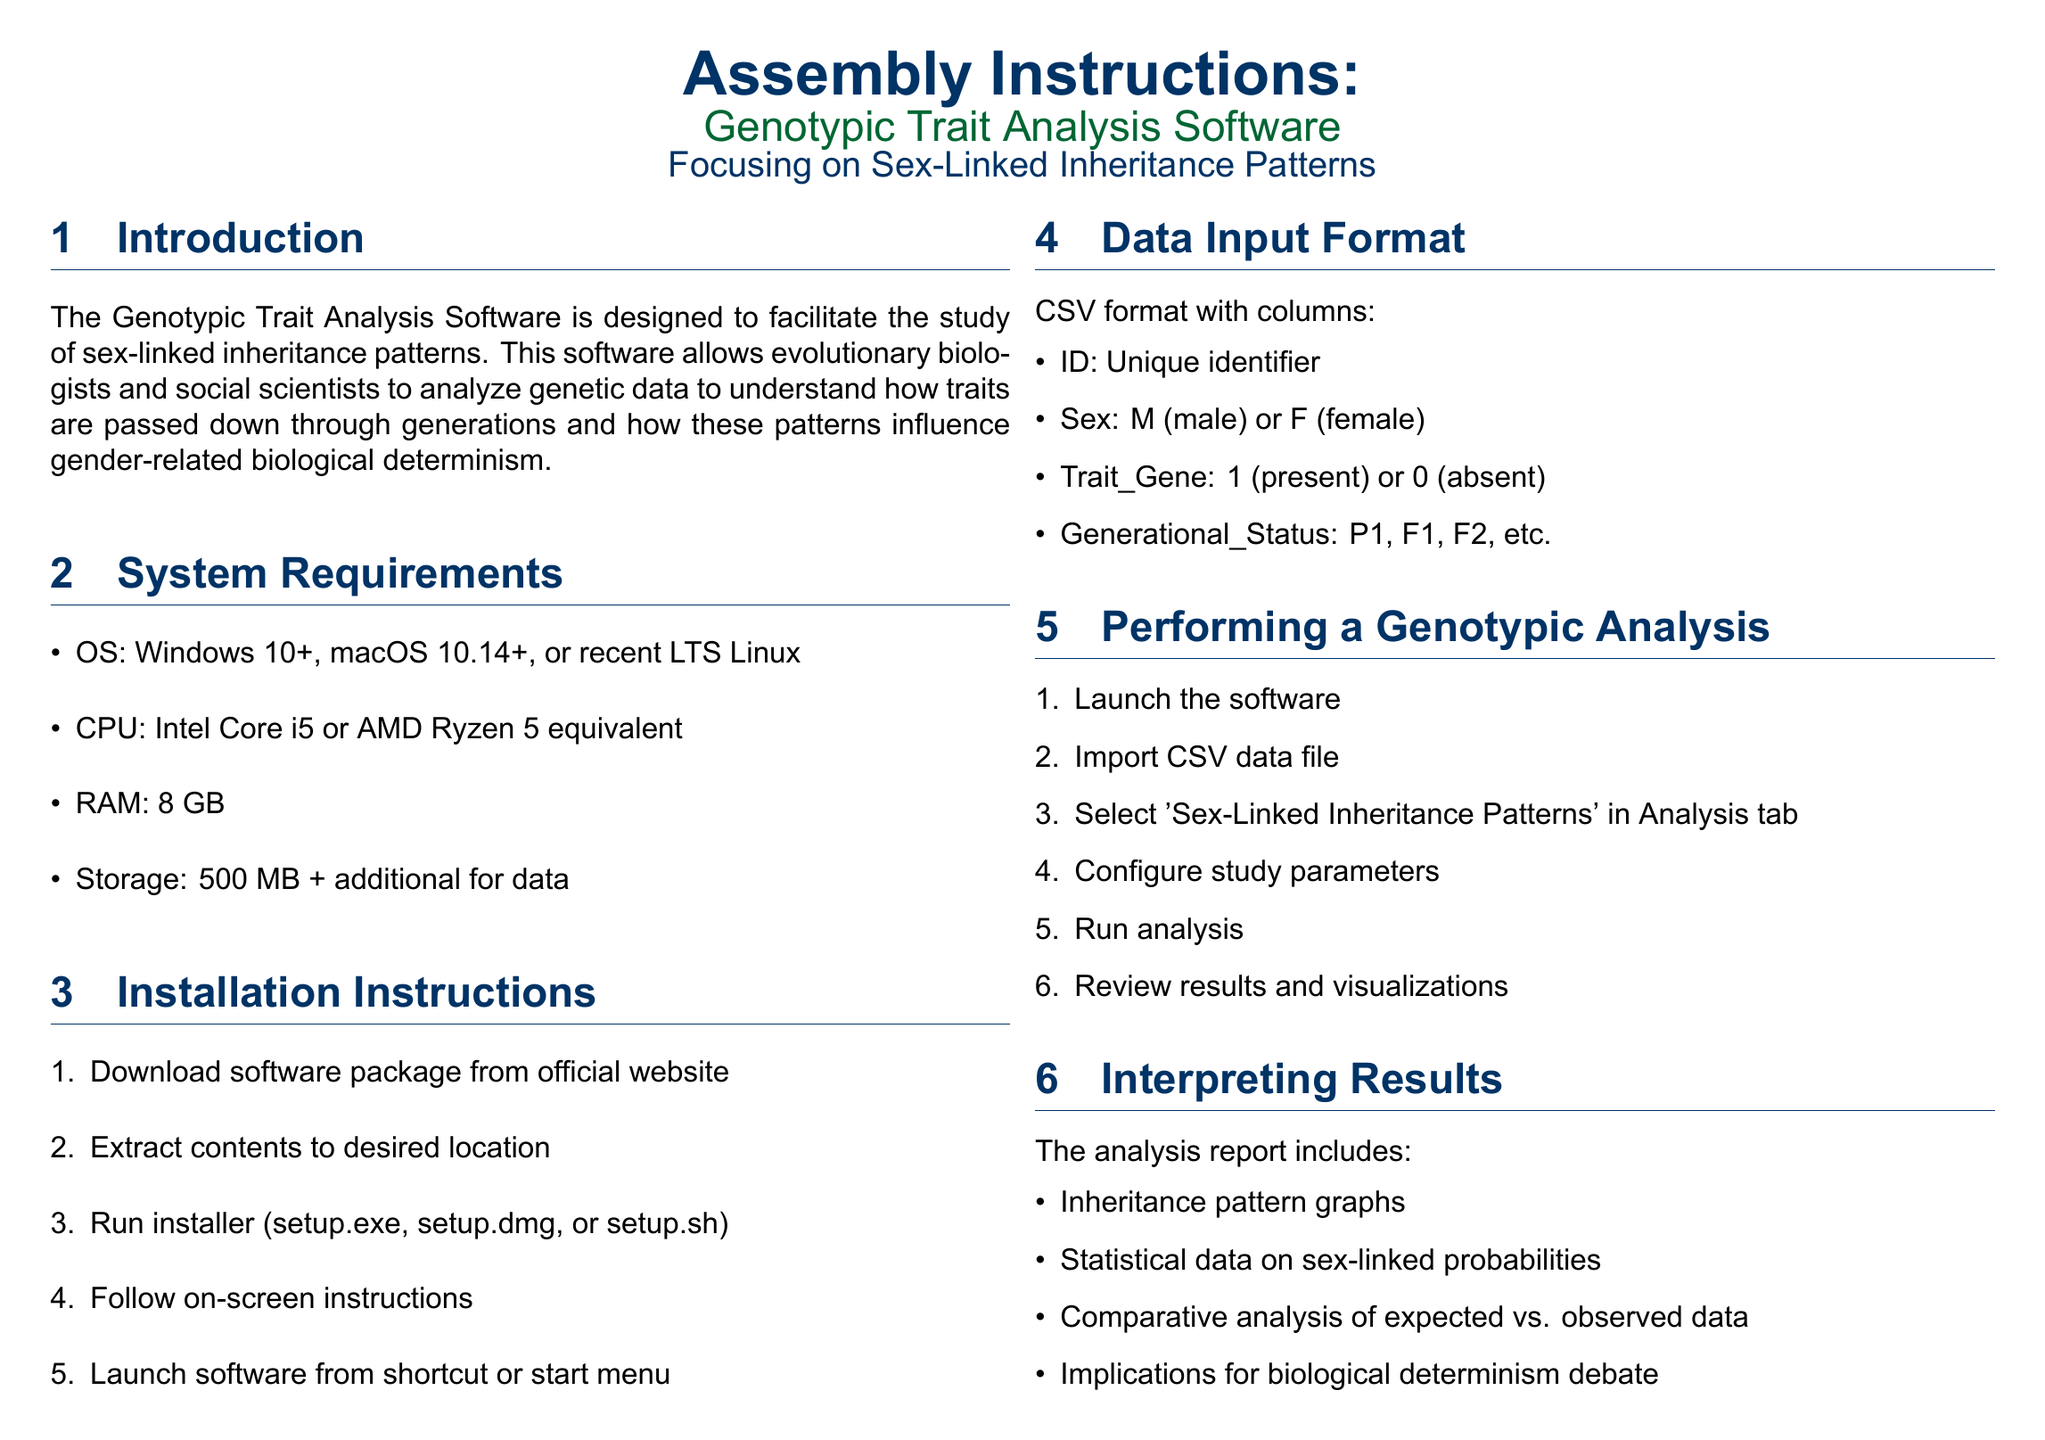What is the software designed to study? The software is designed to facilitate the study of sex-linked inheritance patterns.
Answer: Sex-linked inheritance patterns What are the minimum RAM requirements? The document specifies that the RAM requirement is mentioned under System Requirements.
Answer: 8 GB What file format is required for data input? The required file format for data input is stated in the Data Input Format section.
Answer: CSV Which operating systems are supported? Supported operating systems are listed in the System Requirements.
Answer: Windows 10+, macOS 10.14+, or recent LTS Linux What is the first step to install the software? The installation instructions detail the first step of the installation process.
Answer: Download software package from official website What analysis is selected in the Analysis tab? The analysis to be selected is described in the Performing a Genotypic Analysis section.
Answer: Sex-Linked Inheritance Patterns What type of graphs are included in the analysis report? The type of graphs included is mentioned in the Interpreting Results section.
Answer: Inheritance pattern graphs What is the support email address? The support email address is found in the Support and Documentation section.
Answer: support@genotraitsanalysis.com How many steps are there in the installation instructions? The total number of steps is given in the Installation Instructions section.
Answer: Five steps 